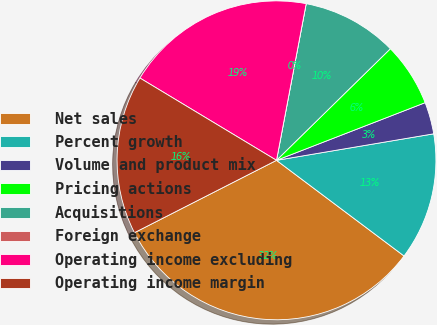<chart> <loc_0><loc_0><loc_500><loc_500><pie_chart><fcel>Net sales<fcel>Percent growth<fcel>Volume and product mix<fcel>Pricing actions<fcel>Acquisitions<fcel>Foreign exchange<fcel>Operating income excluding<fcel>Operating income margin<nl><fcel>32.26%<fcel>12.9%<fcel>3.23%<fcel>6.45%<fcel>9.68%<fcel>0.0%<fcel>19.35%<fcel>16.13%<nl></chart> 